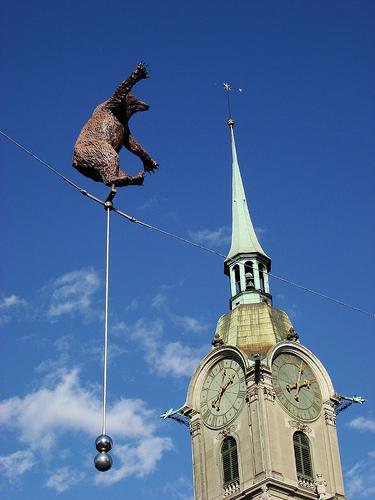Question: where is the bear?
Choices:
A. In the jungle.
B. On pole.
C. In a zoo.
D. On the grass.
Answer with the letter. Answer: B Question: where are the clock hands?
Choices:
A. In the factory.
B. On clocks.
C. On watches.
D. On the ground.
Answer with the letter. Answer: B Question: what color are the clock hands?
Choices:
A. Brown.
B. Black.
C. Gold.
D. White.
Answer with the letter. Answer: C Question: what is the steeple made of?
Choices:
A. Metal.
B. Wood.
C. Plastic.
D. Stone.
Answer with the letter. Answer: D 